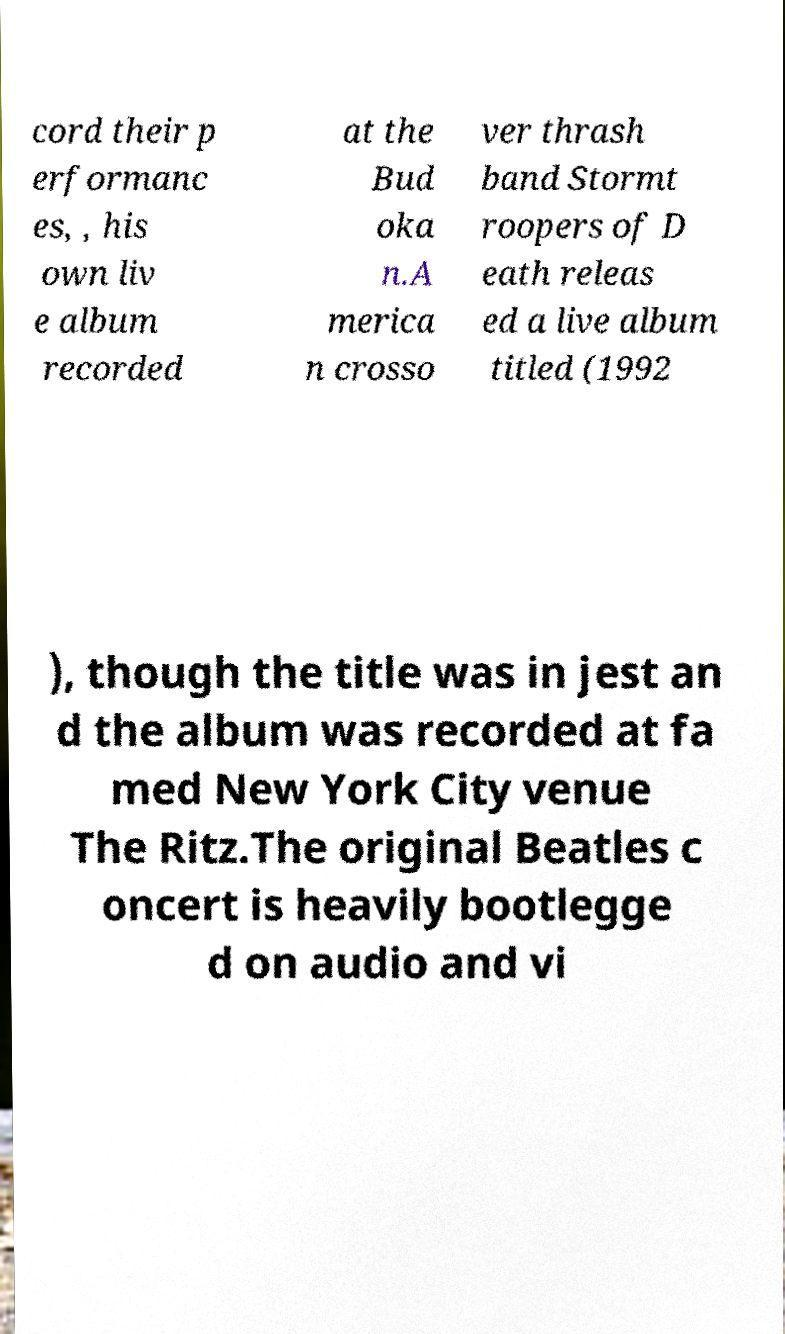What messages or text are displayed in this image? I need them in a readable, typed format. cord their p erformanc es, , his own liv e album recorded at the Bud oka n.A merica n crosso ver thrash band Stormt roopers of D eath releas ed a live album titled (1992 ), though the title was in jest an d the album was recorded at fa med New York City venue The Ritz.The original Beatles c oncert is heavily bootlegge d on audio and vi 